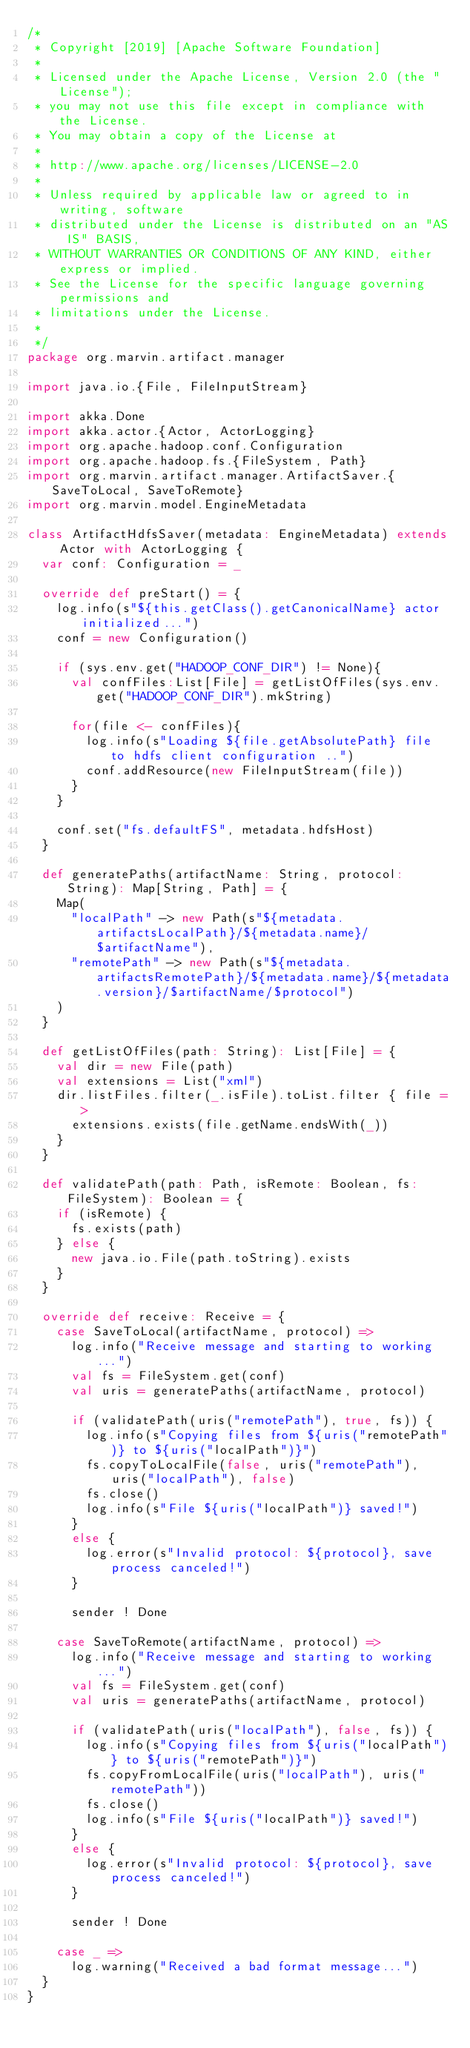<code> <loc_0><loc_0><loc_500><loc_500><_Scala_>/*
 * Copyright [2019] [Apache Software Foundation]
 *
 * Licensed under the Apache License, Version 2.0 (the "License");
 * you may not use this file except in compliance with the License.
 * You may obtain a copy of the License at
 *
 * http://www.apache.org/licenses/LICENSE-2.0
 *
 * Unless required by applicable law or agreed to in writing, software
 * distributed under the License is distributed on an "AS IS" BASIS,
 * WITHOUT WARRANTIES OR CONDITIONS OF ANY KIND, either express or implied.
 * See the License for the specific language governing permissions and
 * limitations under the License.
 *
 */
package org.marvin.artifact.manager

import java.io.{File, FileInputStream}

import akka.Done
import akka.actor.{Actor, ActorLogging}
import org.apache.hadoop.conf.Configuration
import org.apache.hadoop.fs.{FileSystem, Path}
import org.marvin.artifact.manager.ArtifactSaver.{SaveToLocal, SaveToRemote}
import org.marvin.model.EngineMetadata

class ArtifactHdfsSaver(metadata: EngineMetadata) extends Actor with ActorLogging {
  var conf: Configuration = _

  override def preStart() = {
    log.info(s"${this.getClass().getCanonicalName} actor initialized...")
    conf = new Configuration()

    if (sys.env.get("HADOOP_CONF_DIR") != None){
      val confFiles:List[File] = getListOfFiles(sys.env.get("HADOOP_CONF_DIR").mkString)

      for(file <- confFiles){
        log.info(s"Loading ${file.getAbsolutePath} file to hdfs client configuration ..")
        conf.addResource(new FileInputStream(file))
      }
    }

    conf.set("fs.defaultFS", metadata.hdfsHost)
  }

  def generatePaths(artifactName: String, protocol: String): Map[String, Path] = {
    Map(
      "localPath" -> new Path(s"${metadata.artifactsLocalPath}/${metadata.name}/$artifactName"),
      "remotePath" -> new Path(s"${metadata.artifactsRemotePath}/${metadata.name}/${metadata.version}/$artifactName/$protocol")
    )
  }

  def getListOfFiles(path: String): List[File] = {
    val dir = new File(path)
    val extensions = List("xml")
    dir.listFiles.filter(_.isFile).toList.filter { file =>
      extensions.exists(file.getName.endsWith(_))
    }
  }

  def validatePath(path: Path, isRemote: Boolean, fs: FileSystem): Boolean = {
    if (isRemote) {
      fs.exists(path)
    } else {
      new java.io.File(path.toString).exists
    }
  }

  override def receive: Receive = {
    case SaveToLocal(artifactName, protocol) =>
      log.info("Receive message and starting to working...")
      val fs = FileSystem.get(conf)
      val uris = generatePaths(artifactName, protocol)

      if (validatePath(uris("remotePath"), true, fs)) {
        log.info(s"Copying files from ${uris("remotePath")} to ${uris("localPath")}")
        fs.copyToLocalFile(false, uris("remotePath"), uris("localPath"), false)
        fs.close()
        log.info(s"File ${uris("localPath")} saved!")
      }
      else {
        log.error(s"Invalid protocol: ${protocol}, save process canceled!")
      }

      sender ! Done

    case SaveToRemote(artifactName, protocol) =>
      log.info("Receive message and starting to working...")
      val fs = FileSystem.get(conf)
      val uris = generatePaths(artifactName, protocol)

      if (validatePath(uris("localPath"), false, fs)) {
        log.info(s"Copying files from ${uris("localPath")} to ${uris("remotePath")}")
        fs.copyFromLocalFile(uris("localPath"), uris("remotePath"))
        fs.close()
        log.info(s"File ${uris("localPath")} saved!")
      }
      else {
        log.error(s"Invalid protocol: ${protocol}, save process canceled!")
      }

      sender ! Done

    case _ =>
      log.warning("Received a bad format message...")
  }
}
</code> 